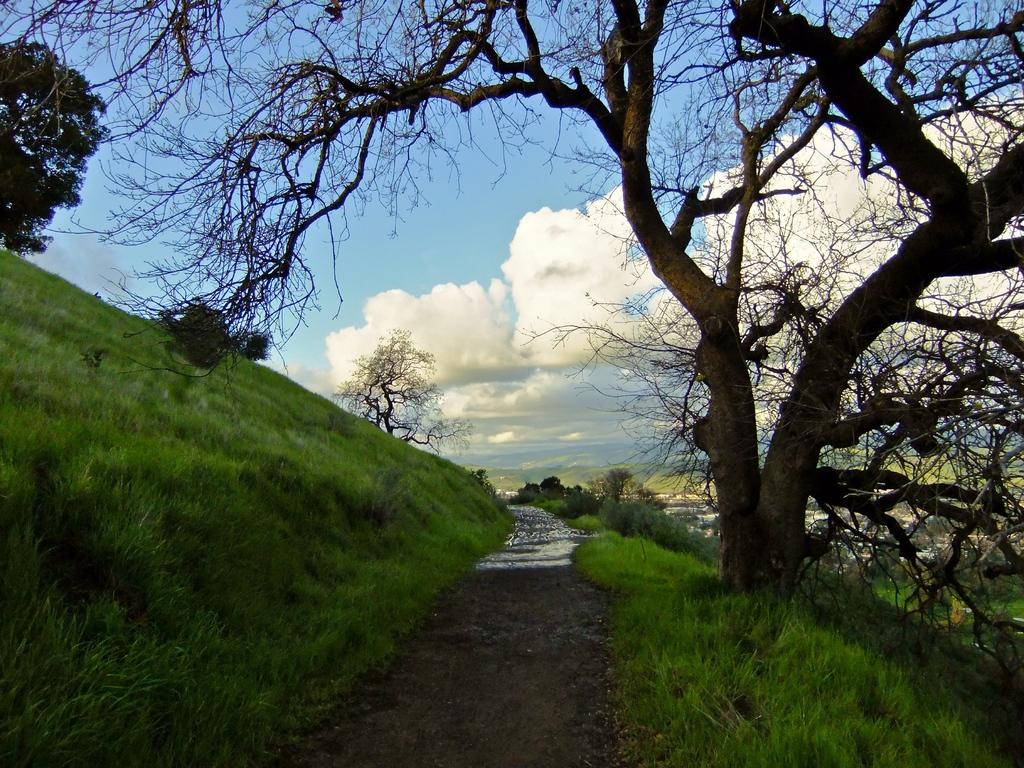What type of vegetation is present in the image? There is grass and trees in the image. What natural element can be seen besides the vegetation? There is water visible in the image. What is visible in the background of the image? The sky is visible in the background of the image. What can be observed in the sky? There are clouds in the sky. What type of event is taking place in the water in the image? There is no event taking place in the water in the image; it is simply visible as a natural element. Can you see anyone swimming in the water in the image? There is no one swimming in the water in the image; it is not a scene of people swimming. 